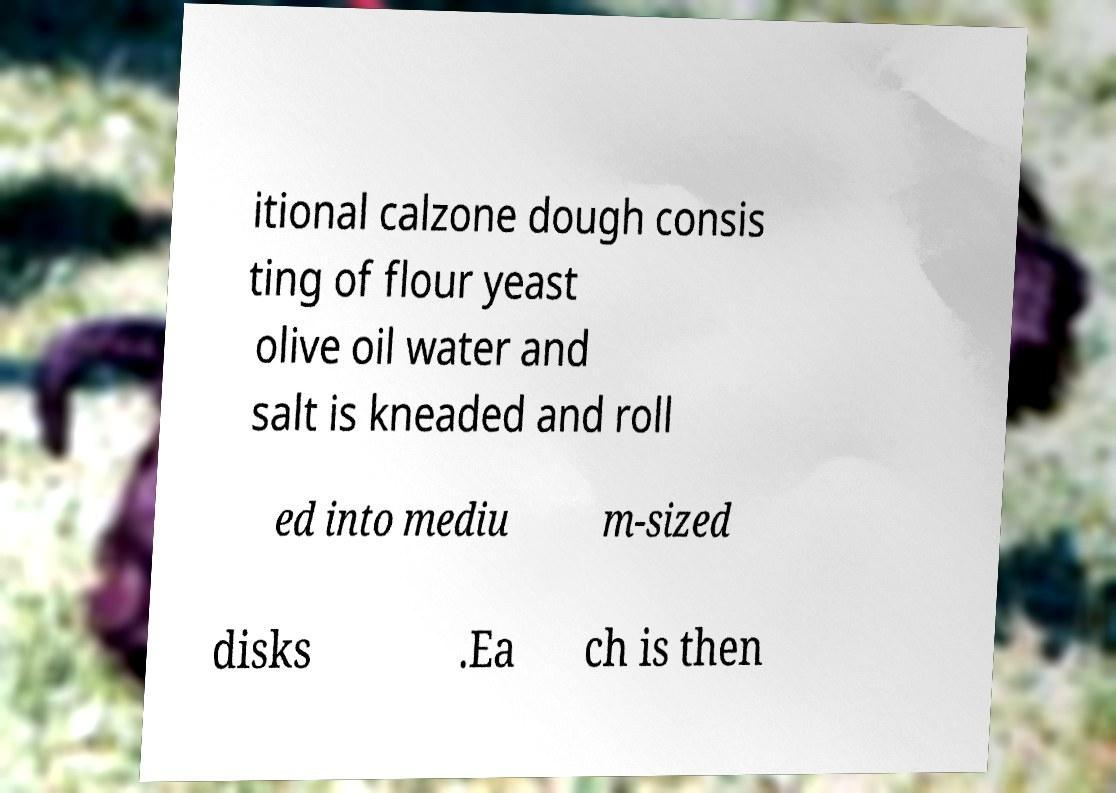Can you read and provide the text displayed in the image?This photo seems to have some interesting text. Can you extract and type it out for me? itional calzone dough consis ting of flour yeast olive oil water and salt is kneaded and roll ed into mediu m-sized disks .Ea ch is then 